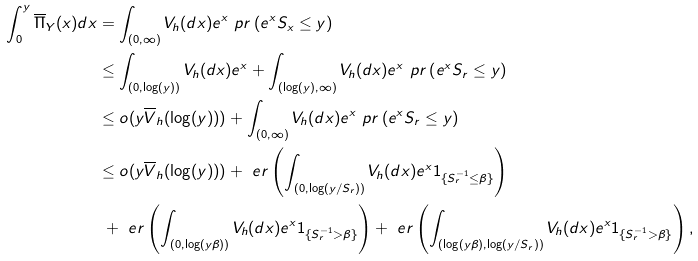<formula> <loc_0><loc_0><loc_500><loc_500>\int ^ { y } _ { 0 } \overline { \Pi } _ { Y } ( x ) d x & = \int _ { ( 0 , \infty ) } V _ { h } ( d x ) e ^ { x } \ p r \left ( e ^ { x } S _ { x } \leq y \right ) \\ & \leq \int _ { ( 0 , \log ( y ) ) } V _ { h } ( d x ) e ^ { x } + \int _ { ( \log ( y ) , \infty ) } V _ { h } ( d x ) e ^ { x } \ p r \left ( e ^ { x } S _ { r } \leq y \right ) \\ & \leq o ( y \overline { V } _ { h } ( \log ( y ) ) ) + \int _ { ( 0 , \infty ) } V _ { h } ( d x ) e ^ { x } \ p r \left ( e ^ { x } S _ { r } \leq y \right ) \\ & \leq o ( y \overline { V } _ { h } ( \log ( y ) ) ) + \ e r \left ( \int _ { ( 0 , \log ( y / S _ { r } ) ) } V _ { h } ( d x ) e ^ { x } 1 _ { \{ S ^ { - 1 } _ { r } \leq \beta \} } \right ) \\ & \ + \ e r \left ( \int _ { ( 0 , \log ( y \beta ) ) } V _ { h } ( d x ) e ^ { x } 1 _ { \{ S ^ { - 1 } _ { r } > \beta \} } \right ) + \ e r \left ( \int _ { ( \log ( y \beta ) , \log ( y / S _ { r } ) ) } V _ { h } ( d x ) e ^ { x } 1 _ { \{ S ^ { - 1 } _ { r } > \beta \} } \right ) ,</formula> 